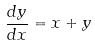Convert formula to latex. <formula><loc_0><loc_0><loc_500><loc_500>\frac { d y } { d x } = x + y</formula> 